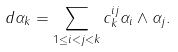Convert formula to latex. <formula><loc_0><loc_0><loc_500><loc_500>d \alpha _ { k } = \sum _ { 1 \leq i < j < k } c ^ { i j } _ { k } \alpha _ { i } \wedge \alpha _ { j } .</formula> 